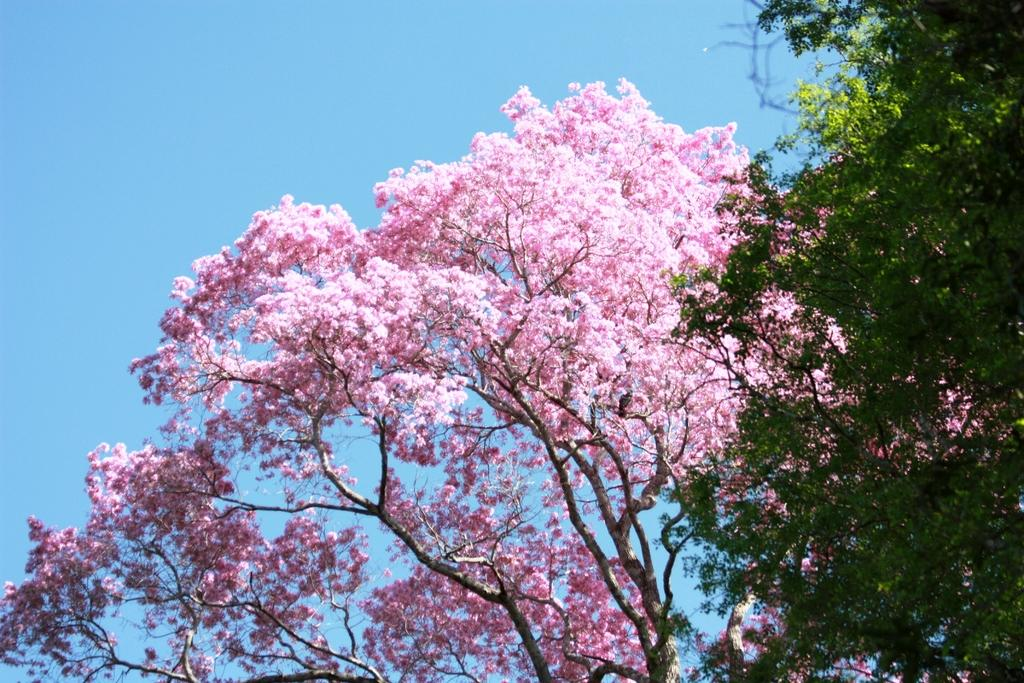What type of flowers are present in the image? There are blossoms in the image. What can be seen in the background of the image? The sky is visible in the background of the image. How many pigs can be seen interacting with the blossoms in the image? There are no pigs present in the image; it features blossoms and a sky background. Are there any giants visible in the image? There are no giants present in the image. 